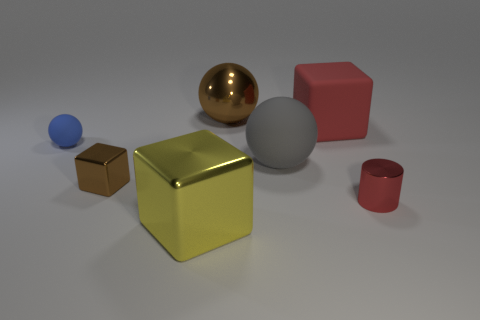Subtract all gray rubber spheres. How many spheres are left? 2 Subtract all yellow cubes. How many cubes are left? 2 Subtract all balls. How many objects are left? 4 Subtract 1 balls. How many balls are left? 2 Add 1 large red blocks. How many objects exist? 8 Subtract 1 brown blocks. How many objects are left? 6 Subtract all cyan spheres. Subtract all green blocks. How many spheres are left? 3 Subtract all brown spheres. How many cyan cylinders are left? 0 Subtract all big gray cubes. Subtract all gray balls. How many objects are left? 6 Add 7 brown shiny spheres. How many brown shiny spheres are left? 8 